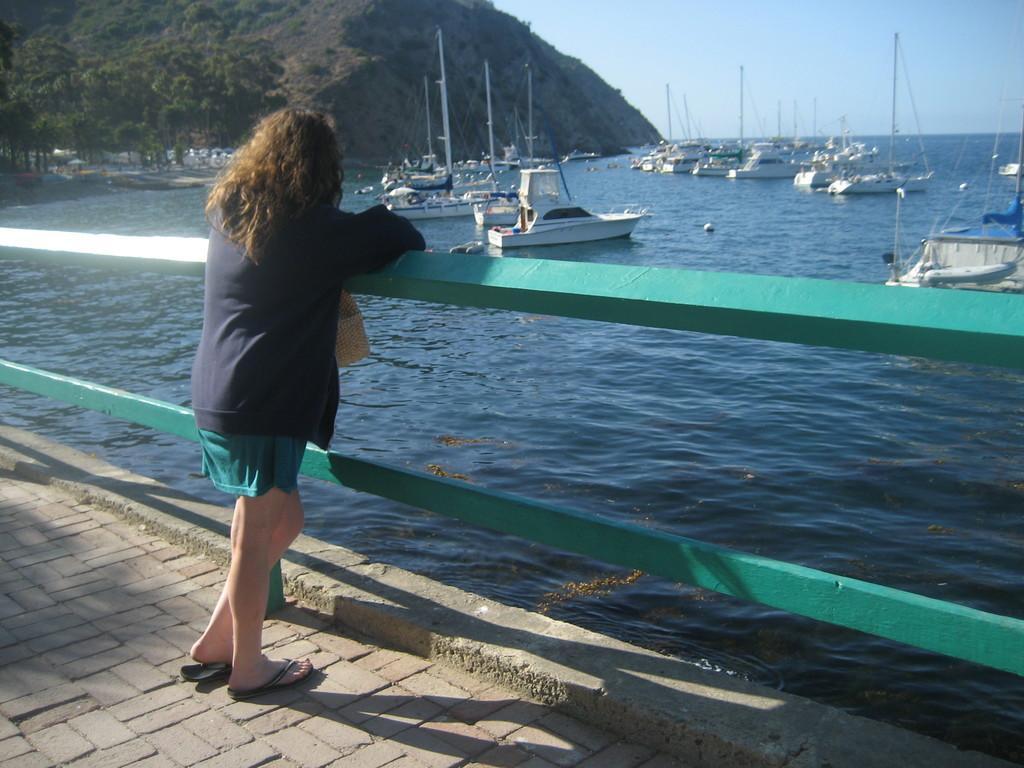Can you describe this image briefly? In this image there is a lady standing on the path and she placed her hands on the wooden fence. In the background there are so many ships on the river, trees, mountains and the sky. 